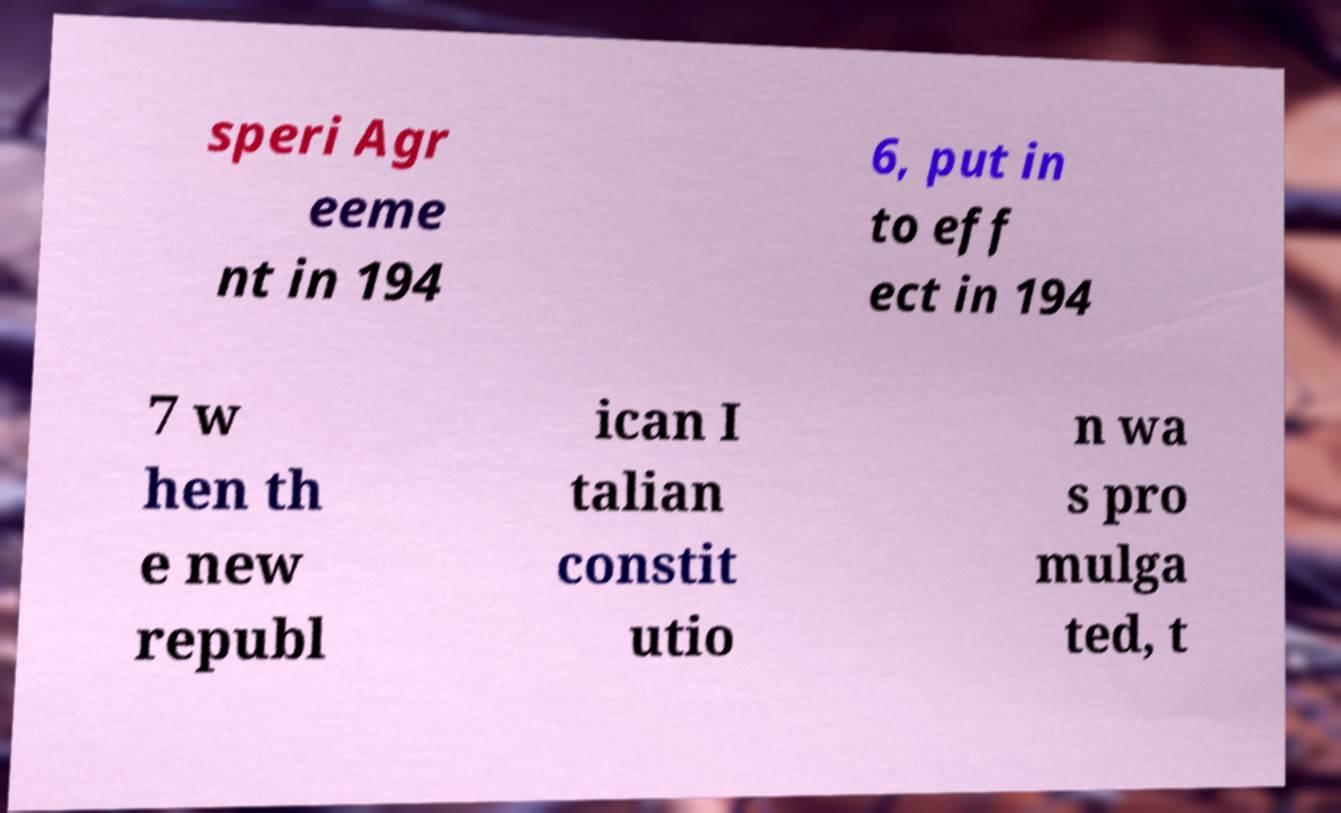What messages or text are displayed in this image? I need them in a readable, typed format. speri Agr eeme nt in 194 6, put in to eff ect in 194 7 w hen th e new republ ican I talian constit utio n wa s pro mulga ted, t 